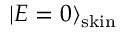<formula> <loc_0><loc_0><loc_500><loc_500>| E = 0 \rangle _ { s k i n }</formula> 